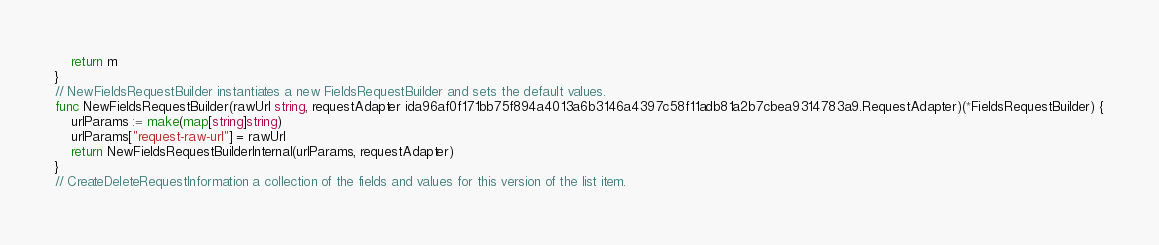<code> <loc_0><loc_0><loc_500><loc_500><_Go_>    return m
}
// NewFieldsRequestBuilder instantiates a new FieldsRequestBuilder and sets the default values.
func NewFieldsRequestBuilder(rawUrl string, requestAdapter ida96af0f171bb75f894a4013a6b3146a4397c58f11adb81a2b7cbea9314783a9.RequestAdapter)(*FieldsRequestBuilder) {
    urlParams := make(map[string]string)
    urlParams["request-raw-url"] = rawUrl
    return NewFieldsRequestBuilderInternal(urlParams, requestAdapter)
}
// CreateDeleteRequestInformation a collection of the fields and values for this version of the list item.</code> 